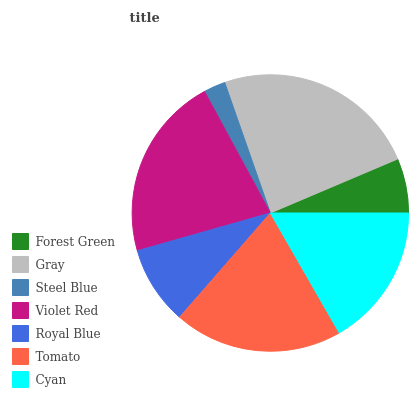Is Steel Blue the minimum?
Answer yes or no. Yes. Is Gray the maximum?
Answer yes or no. Yes. Is Gray the minimum?
Answer yes or no. No. Is Steel Blue the maximum?
Answer yes or no. No. Is Gray greater than Steel Blue?
Answer yes or no. Yes. Is Steel Blue less than Gray?
Answer yes or no. Yes. Is Steel Blue greater than Gray?
Answer yes or no. No. Is Gray less than Steel Blue?
Answer yes or no. No. Is Cyan the high median?
Answer yes or no. Yes. Is Cyan the low median?
Answer yes or no. Yes. Is Forest Green the high median?
Answer yes or no. No. Is Royal Blue the low median?
Answer yes or no. No. 